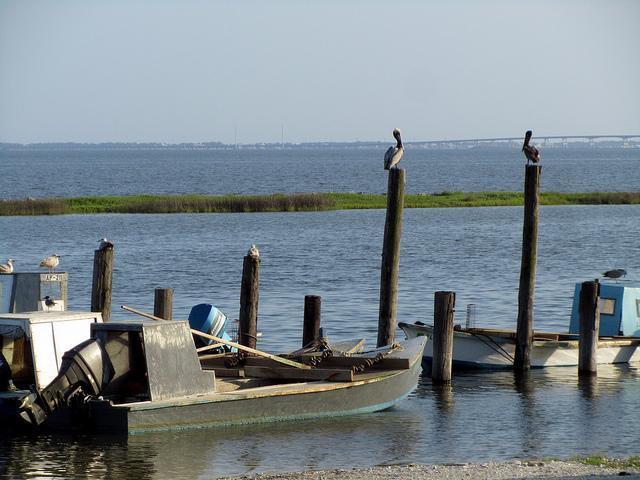How many boats are in the photo?
Give a very brief answer. 3. How many people are not playing with the wii?
Give a very brief answer. 0. 